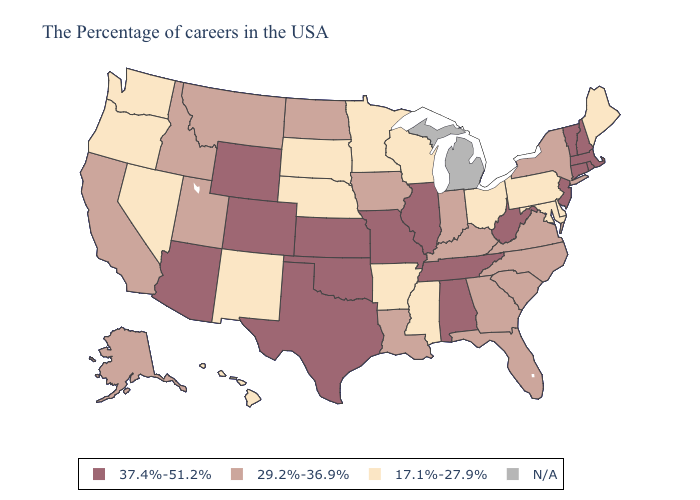Does the first symbol in the legend represent the smallest category?
Keep it brief. No. Which states hav the highest value in the Northeast?
Give a very brief answer. Massachusetts, Rhode Island, New Hampshire, Vermont, Connecticut, New Jersey. Name the states that have a value in the range 17.1%-27.9%?
Give a very brief answer. Maine, Delaware, Maryland, Pennsylvania, Ohio, Wisconsin, Mississippi, Arkansas, Minnesota, Nebraska, South Dakota, New Mexico, Nevada, Washington, Oregon, Hawaii. Does Montana have the lowest value in the USA?
Answer briefly. No. What is the highest value in states that border North Carolina?
Write a very short answer. 37.4%-51.2%. Name the states that have a value in the range N/A?
Concise answer only. Michigan. Name the states that have a value in the range 29.2%-36.9%?
Quick response, please. New York, Virginia, North Carolina, South Carolina, Florida, Georgia, Kentucky, Indiana, Louisiana, Iowa, North Dakota, Utah, Montana, Idaho, California, Alaska. How many symbols are there in the legend?
Be succinct. 4. Name the states that have a value in the range N/A?
Write a very short answer. Michigan. What is the value of Florida?
Write a very short answer. 29.2%-36.9%. Name the states that have a value in the range N/A?
Concise answer only. Michigan. Name the states that have a value in the range 37.4%-51.2%?
Give a very brief answer. Massachusetts, Rhode Island, New Hampshire, Vermont, Connecticut, New Jersey, West Virginia, Alabama, Tennessee, Illinois, Missouri, Kansas, Oklahoma, Texas, Wyoming, Colorado, Arizona. 